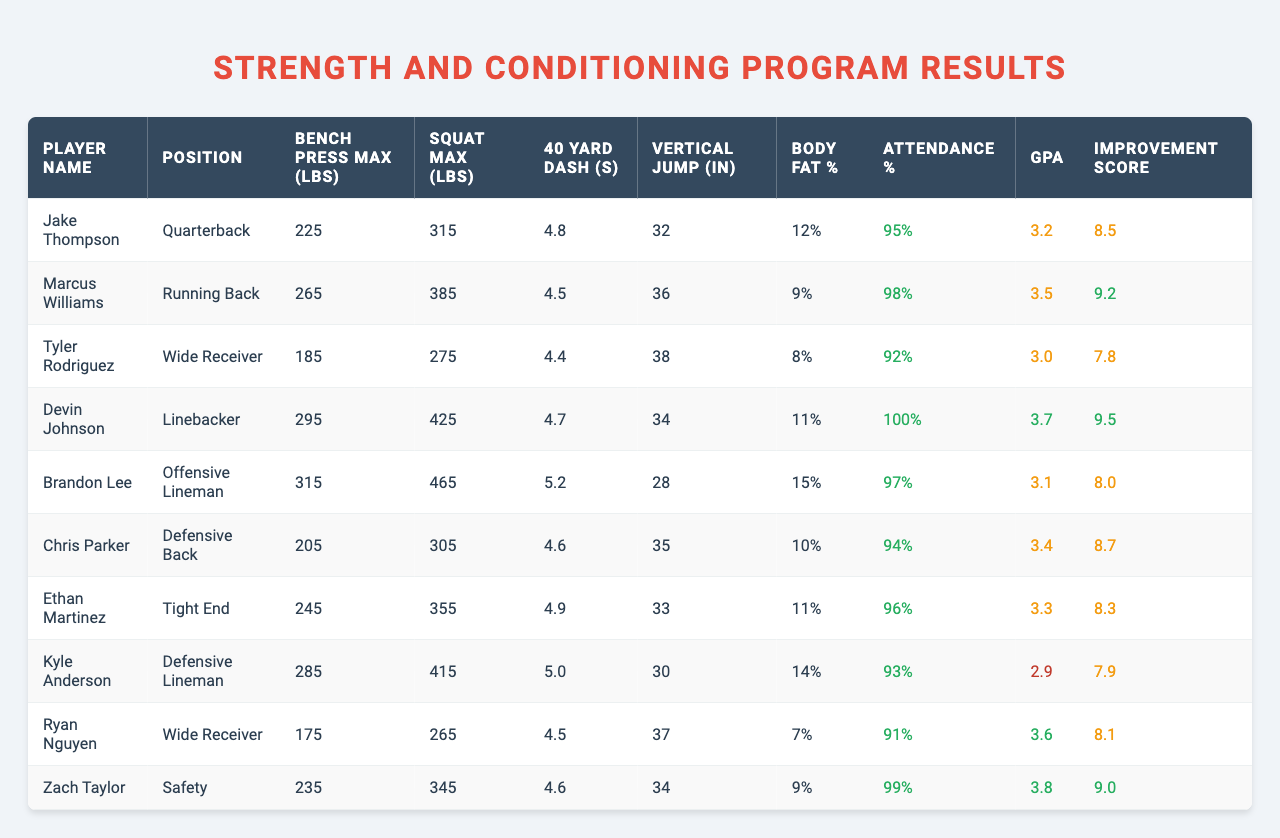What is the maximum bench press weight recorded? The maximum bench press weight is the highest value in the "Bench Press Max (lbs)" column, which is 315 lbs by Brandon Lee.
Answer: 315 lbs Who has the lowest body fat percentage? The lowest body fat percentage is found in the "Body Fat %" column, which is 7% for Ryan Nguyen.
Answer: 7% What is the average GPA of all players? To find the average GPA, sum all GPAs (3.2 + 3.5 + 3.0 + 3.7 + 3.1 + 3.4 + 3.3 + 2.9 + 3.6 + 3.8) = 34.5, then divide by 10 (the number of players), 34.5 / 10 = 3.45.
Answer: 3.45 Is there any player with a 100% attendance rate? By checking the "Attendance %" column, Devin Johnson has an attendance percentage of 100%.
Answer: Yes Who scored the highest Improvement Score, and what was it? The highest Improvement Score is in the "Improvement Score" column, which is 9.5 by Devin Johnson.
Answer: Devin Johnson, 9.5 What is the average squat max of the quarterbacks? The squat max for the quarterbacks are: Jake Thompson (315), and Ryan Nguyen (265). Their average is (315 + 265) / 2 = 290 lbs.
Answer: 290 lbs Which position has the largest average bench press max? The average bench press max for each position needs to be calculated: Quarterback (225), Running Back (265), Wide Receiver (185 + 175), Linebacker (295), Offensive Lineman (315), Defensive Back (205), Tight End (245), Defensive Lineman (285), Safety (235). The average for Offensive Lineman is highest at 315 lbs.
Answer: Offensive Lineman What is the attendance percentage of the player with the highest squat max? The highest squat max is 465 lbs by Brandon Lee, and his attendance percentage is 97%.
Answer: 97% Is there a correlation between vertical jump and 40-yard dash time for the players? To evaluate correlation, we look at respective values. Players with higher vertical jumps do tend to have lower dash times, but it requires calculation for a definitive correlation. Based on observation, it appears there is some negative correlation.
Answer: Yes, a negative correlation is observed How many players scored an Improvement Score above 9? Counting the scores above 9 from the "Improvement Score" column, Devin Johnson (9.5), Marcus Williams (9.2), and Zach Taylor (9.0) gives a total of 3 players.
Answer: 3 Players 